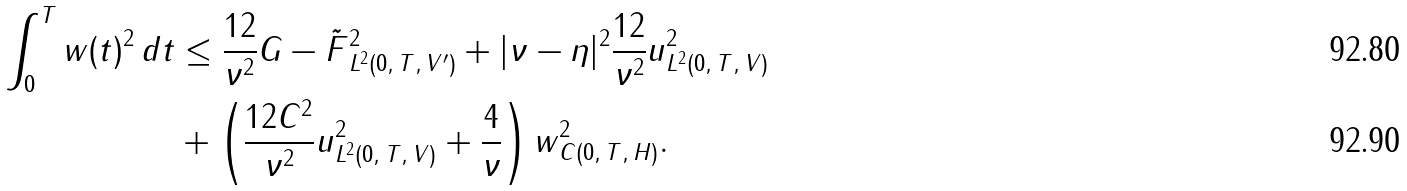<formula> <loc_0><loc_0><loc_500><loc_500>\int _ { 0 } ^ { T } \| w ( t ) \| ^ { 2 } \, d t & \leq \frac { 1 2 } { \nu ^ { 2 } } \| G - \tilde { F } \| _ { L ^ { 2 } ( 0 , \, T , \, V ^ { \prime } ) } ^ { 2 } + | \nu - \eta | ^ { 2 } \frac { 1 2 } { \nu ^ { 2 } } \| u \| _ { L ^ { 2 } ( 0 , \, T , \, V ) } ^ { 2 } \\ & + \left ( \frac { 1 2 C ^ { 2 } } { \nu ^ { 2 } } \| u \| _ { L ^ { 2 } ( 0 , \, T , \, V ) } ^ { 2 } + \frac { 4 } { \nu } \right ) \| w \| _ { C ( 0 , \, T , \, H ) } ^ { 2 } .</formula> 